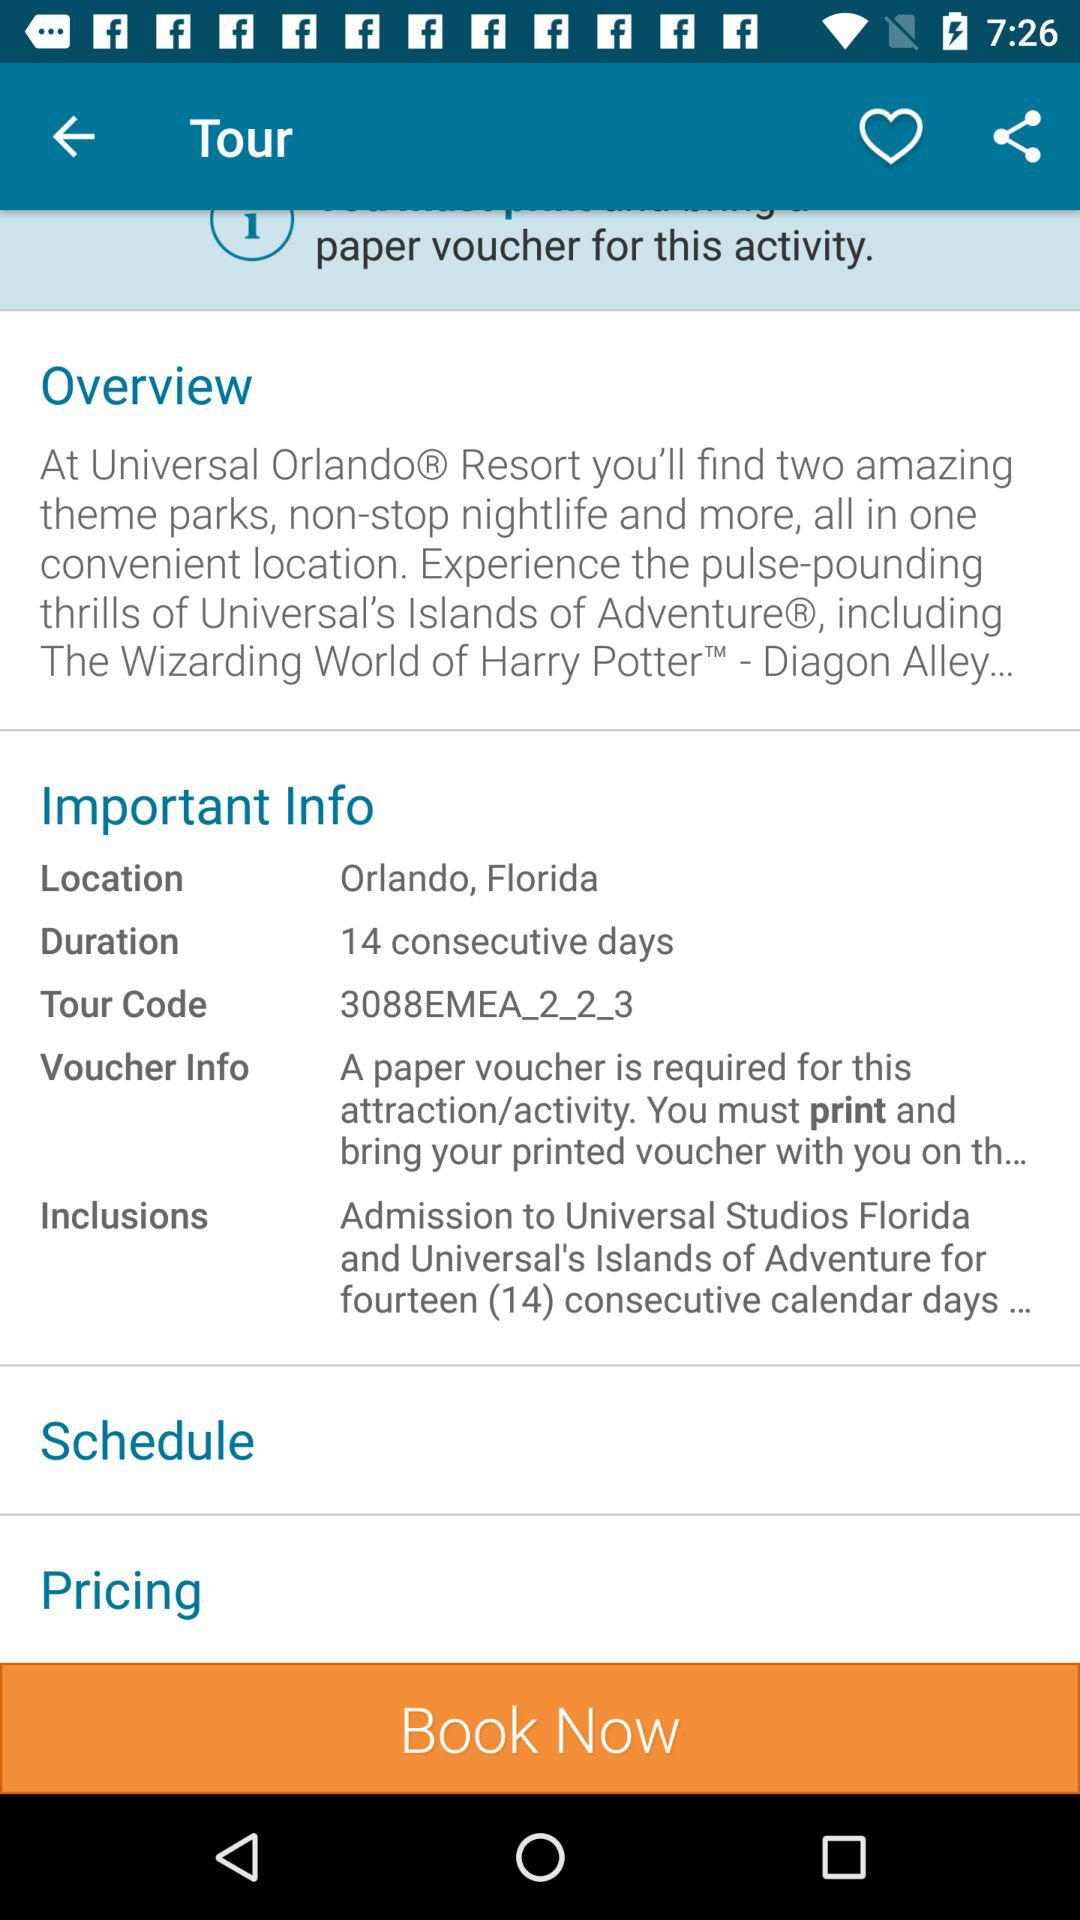How many days does the Universal Orlando Resort ticket last?
Answer the question using a single word or phrase. 14 consecutive days 